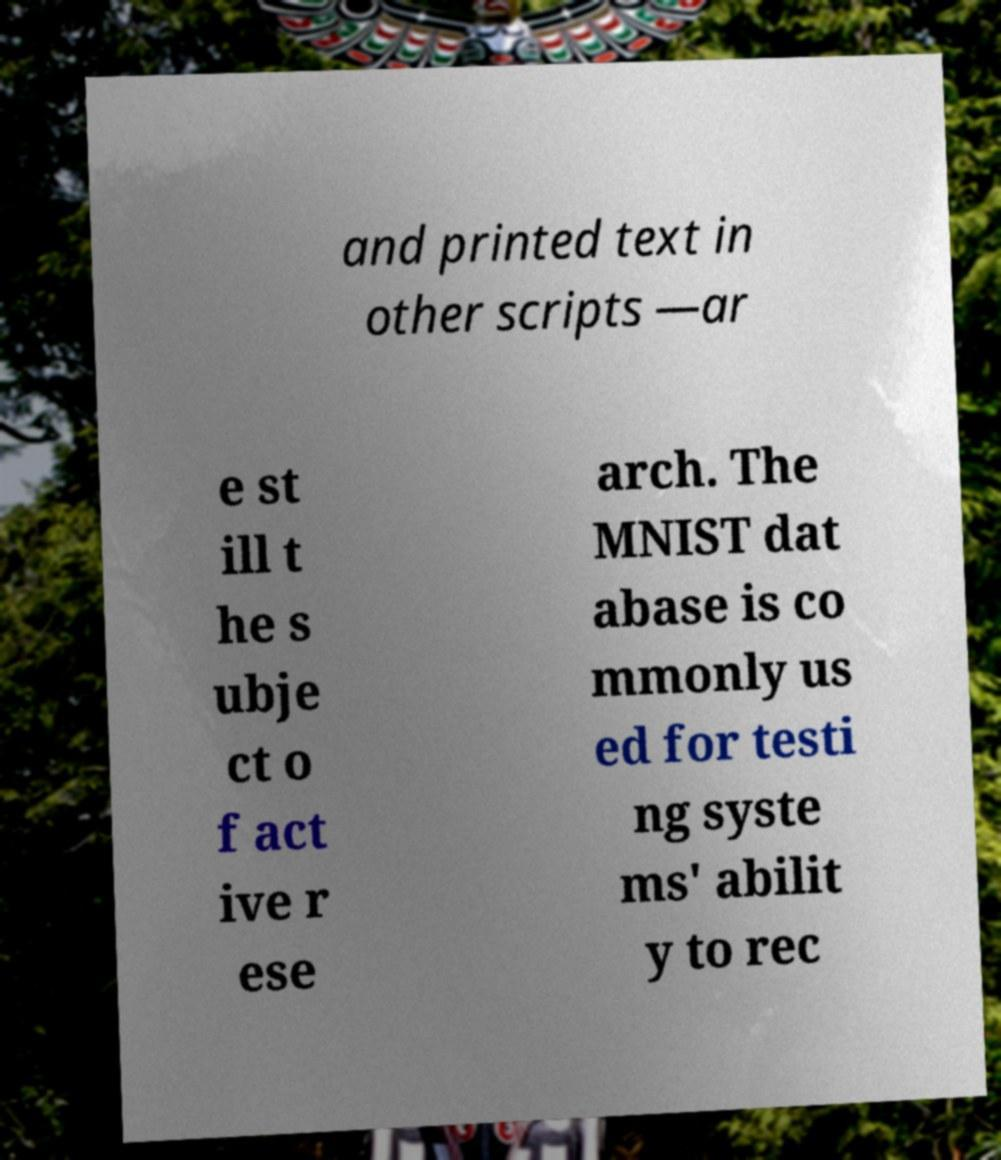Can you accurately transcribe the text from the provided image for me? and printed text in other scripts —ar e st ill t he s ubje ct o f act ive r ese arch. The MNIST dat abase is co mmonly us ed for testi ng syste ms' abilit y to rec 